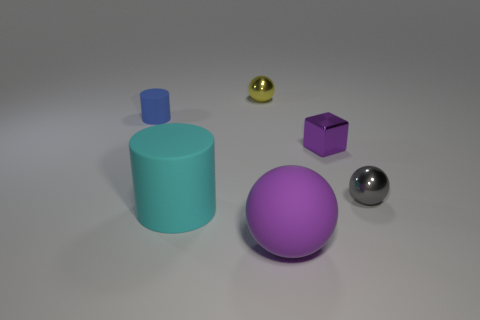Add 1 big balls. How many objects exist? 7 Subtract all cubes. How many objects are left? 5 Add 3 small blue objects. How many small blue objects exist? 4 Subtract 0 yellow cubes. How many objects are left? 6 Subtract all matte balls. Subtract all cylinders. How many objects are left? 3 Add 6 purple rubber spheres. How many purple rubber spheres are left? 7 